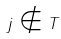<formula> <loc_0><loc_0><loc_500><loc_500>j \notin T</formula> 